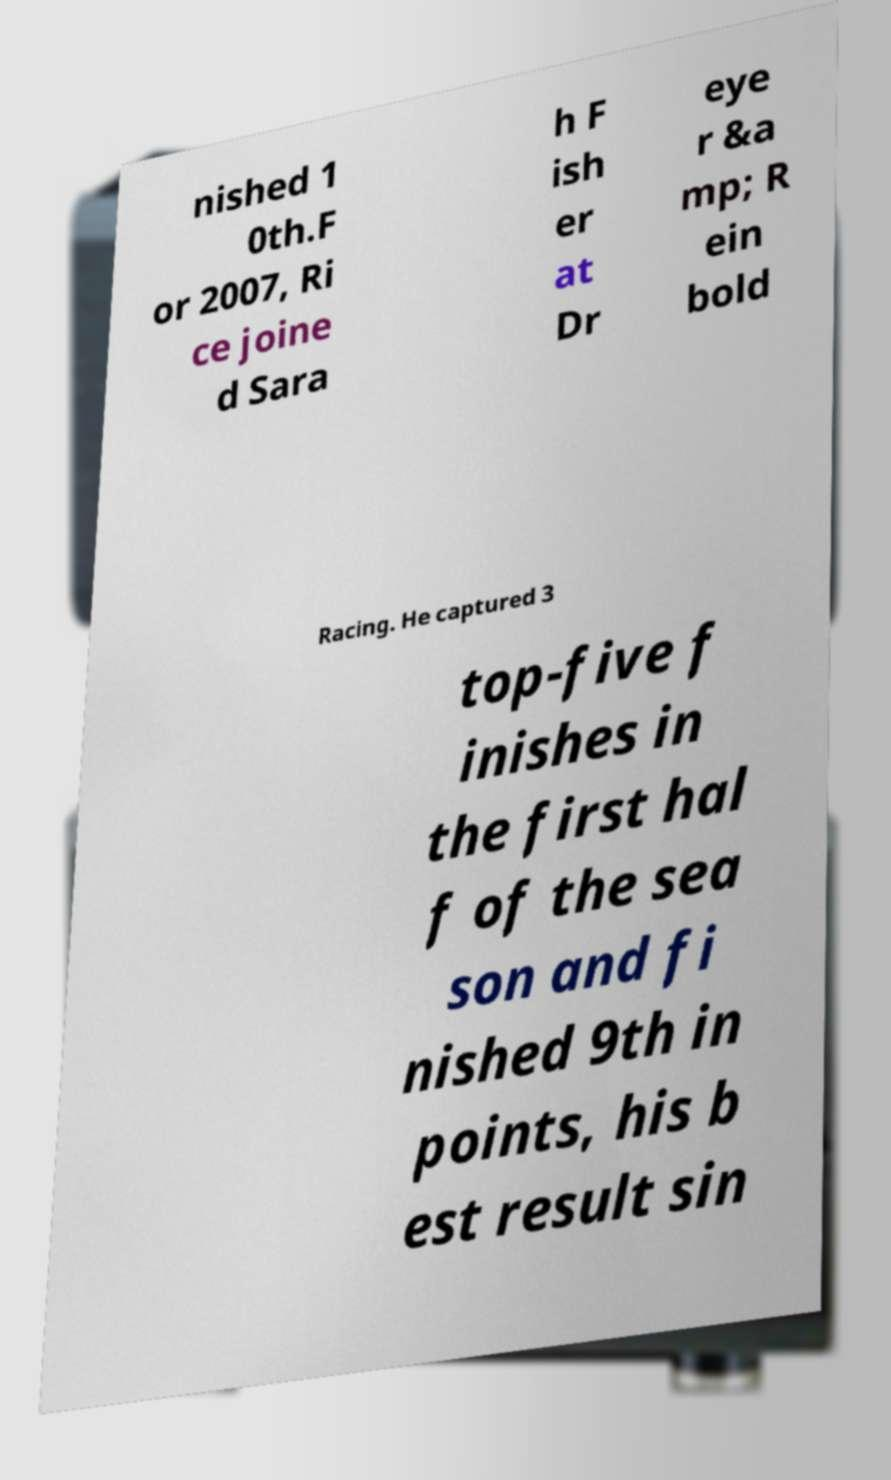Could you assist in decoding the text presented in this image and type it out clearly? nished 1 0th.F or 2007, Ri ce joine d Sara h F ish er at Dr eye r &a mp; R ein bold Racing. He captured 3 top-five f inishes in the first hal f of the sea son and fi nished 9th in points, his b est result sin 